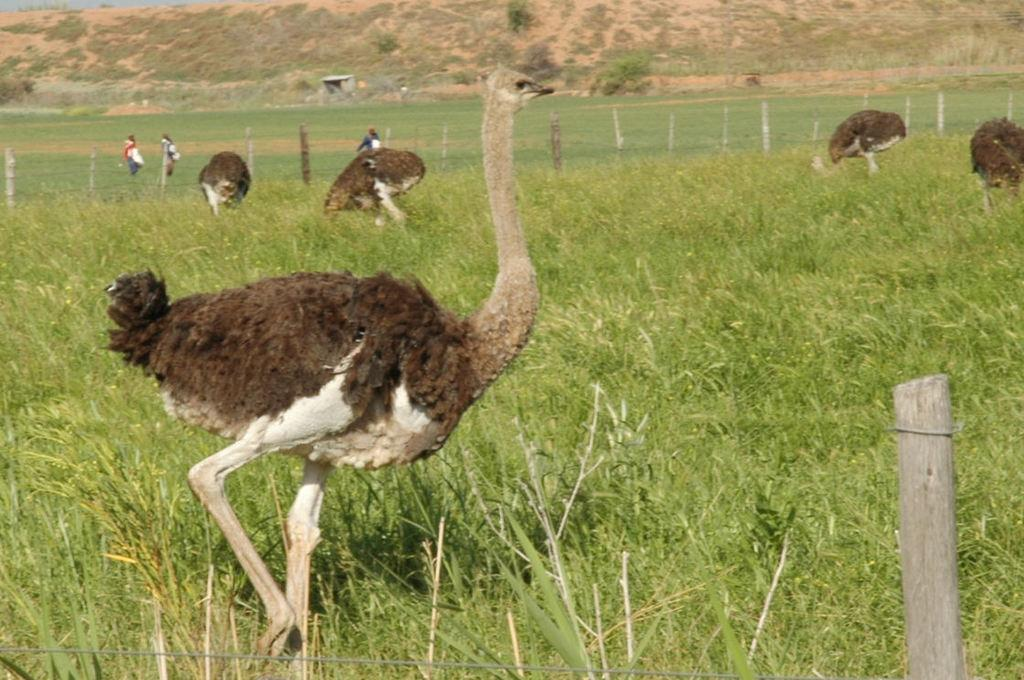What type of animals can be seen in the image? There are birds in the image. What other living beings are present in the image? There are persons in the image. What type of vegetation is visible in the image? There is grass and plants in the image. What kind of barrier can be seen in the image? There is a fence in the image. What type of error can be seen in the image? There is no error present in the image; it is a clear depiction of birds, persons, grass, plants, and a fence. Can you tell me where the badge is located in the image? There is no badge present in the image. 